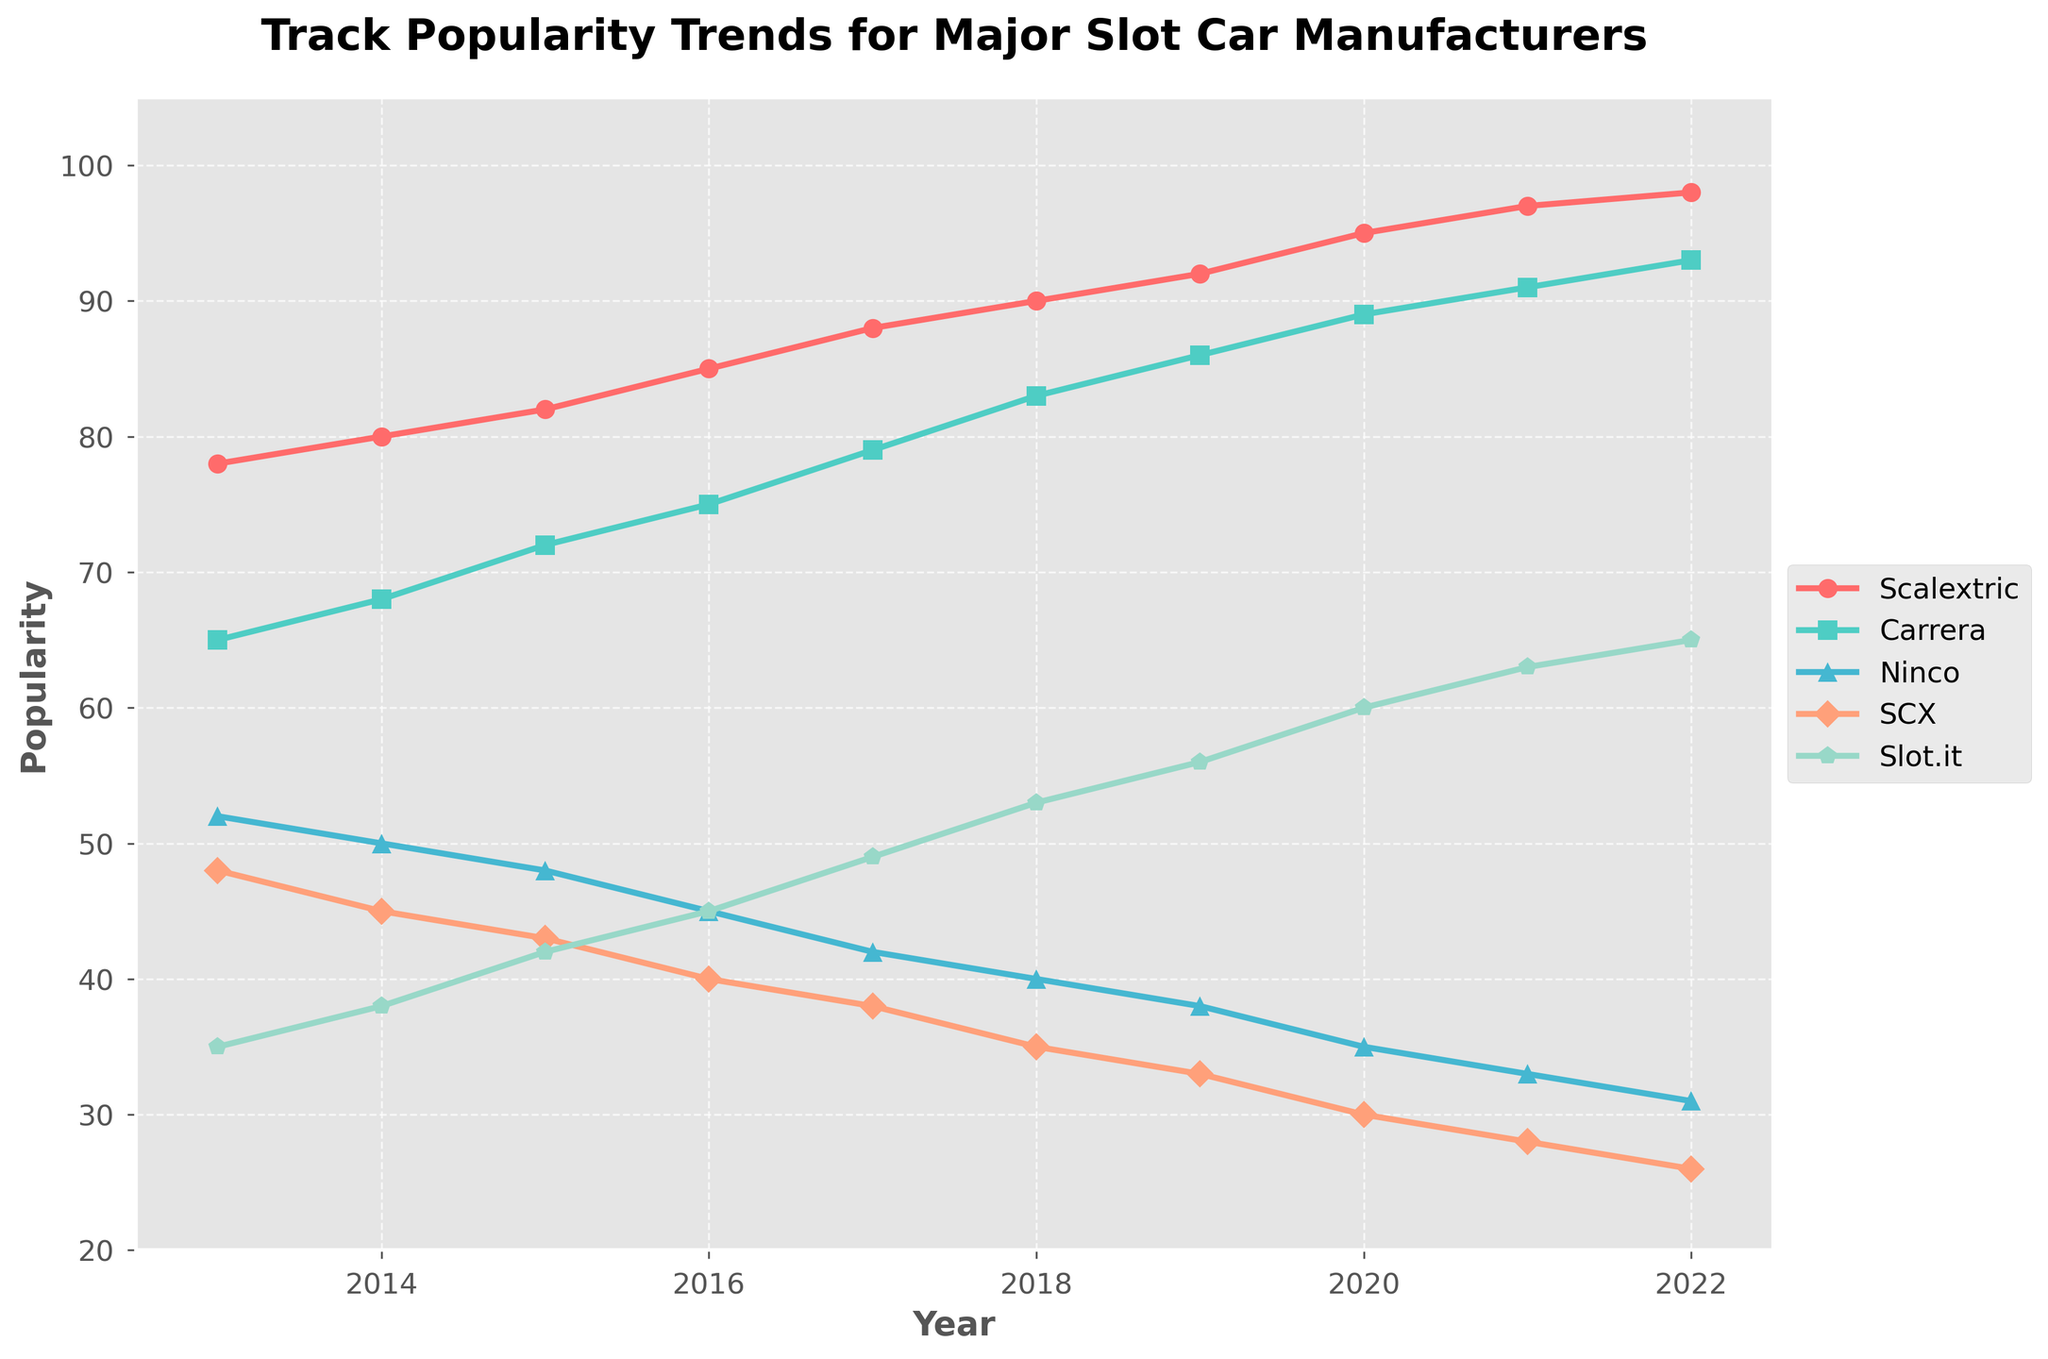What is the trend of Scalextric's popularity from 2013 to 2022? Scalextric's popularity trend shows a consistent increase from 78 in 2013 to 98 in 2022. The value increases every year without any decline.
Answer: It increased How did Slot.it's popularity change from 2013 to 2022? Slot.it's popularity increased from 35 in 2013 to 65 in 2022. Every year, there is a growth, with notable increments in recent years.
Answer: It increased Which year did Carrera surpass a popularity score of 80? Looking at the trend for Carrera, its popularity surpasses 80 in the year 2018, where it reaches 83.
Answer: 2018 Between Ninco and SCX, which manufacturer had a higher popularity in 2020? In 2020, Ninco's popularity was 35, and SCX's popularity was 30. Comparing these two values, Ninco had a higher popularity.
Answer: Ninco In which year did SCX's popularity drop below 40 for good? Observing SCX's trend, the popularity dropped below 40 in 2016 when it was 38, and hasn't risen above 40 since.
Answer: 2016 What is the visual representation (color and marker) for Ninco? The visual representation for Ninco uses a green color in the chart with a triangle marker.
Answer: Green with triangle marker Compare the trends of Scalextric and SCX. Which one shows a steady increase, and which shows a steady decrease? Scalextric shows a steady increase in popularity, rising year after year from 78 to 98. In contrast, SCX shows a steady decrease, dropping from 48 to 26 over the same period.
Answer: Scalextric increased, SCX decreased Which manufacturer had the lowest popularity in 2022? In 2022, SCX had the lowest popularity score, which was 26, compared to the other manufacturers.
Answer: SCX Did any manufacturer's popularity remain constant for a year? Examining the trends, there is no manufacturer whose popularity remained exactly the same for any of the consecutive years.
Answer: No Can you find the year when two manufacturers had the exact same popularity score? Comparing the trends, there is no single year where two manufacturers have exactly identical popularity scores.
Answer: No 